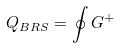<formula> <loc_0><loc_0><loc_500><loc_500>Q _ { B R S } = \oint G ^ { + }</formula> 